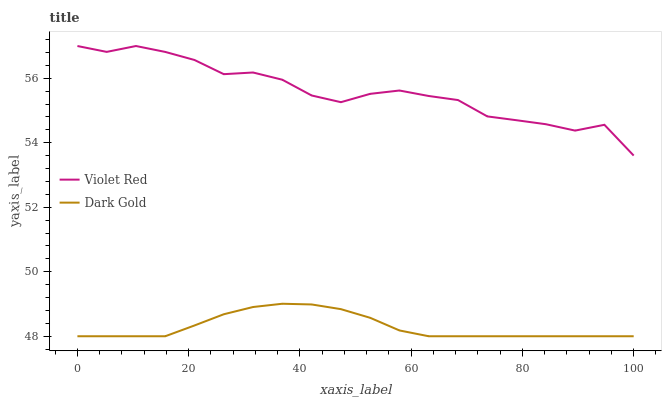Does Dark Gold have the minimum area under the curve?
Answer yes or no. Yes. Does Violet Red have the maximum area under the curve?
Answer yes or no. Yes. Does Dark Gold have the maximum area under the curve?
Answer yes or no. No. Is Dark Gold the smoothest?
Answer yes or no. Yes. Is Violet Red the roughest?
Answer yes or no. Yes. Is Dark Gold the roughest?
Answer yes or no. No. Does Dark Gold have the highest value?
Answer yes or no. No. Is Dark Gold less than Violet Red?
Answer yes or no. Yes. Is Violet Red greater than Dark Gold?
Answer yes or no. Yes. Does Dark Gold intersect Violet Red?
Answer yes or no. No. 